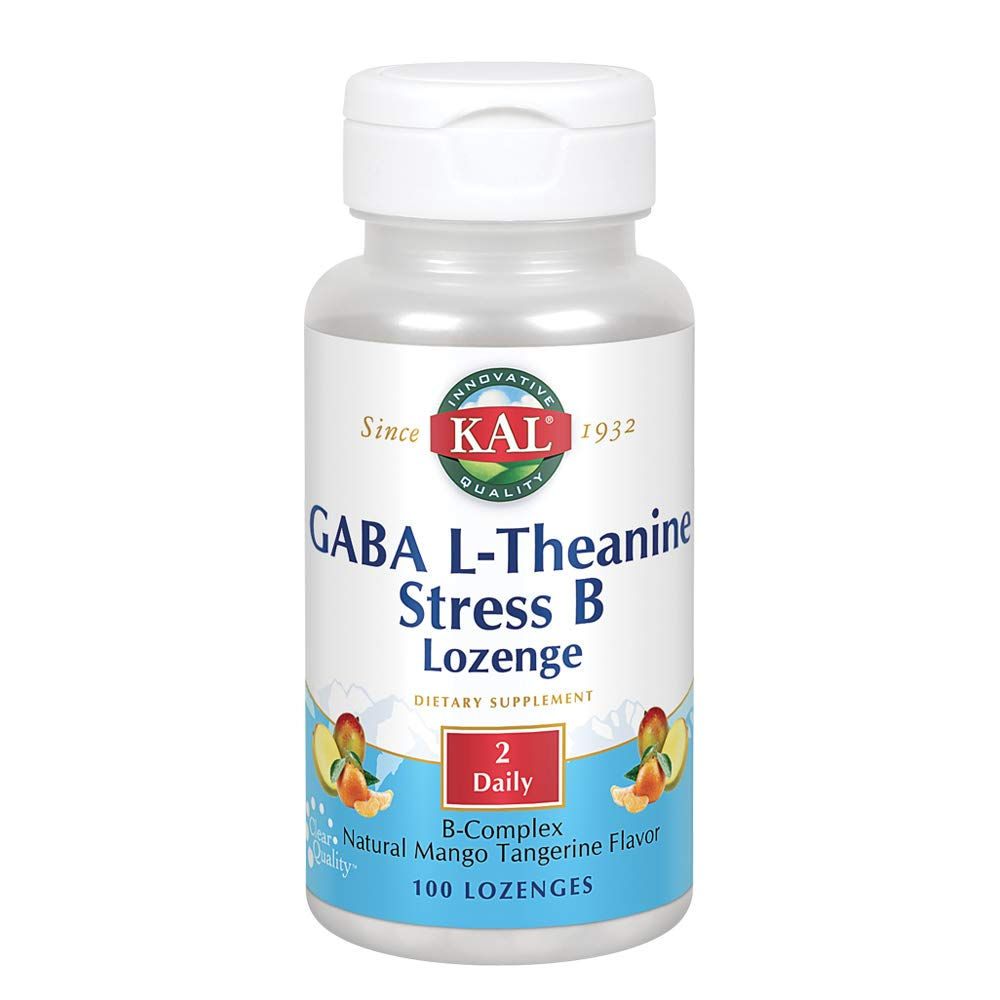How might the flavor of this supplement affect its appeal and consumption? The natural mango tangerine flavor is likely to enhance the appeal and consumption of this supplement. Pleasant flavors can make taking daily supplements a more enjoyable experience, thereby increasing adherence to the recommended dosage. Additionally, fruity flavors like mango and tangerine are generally popular and may mask any potential bitterness of the active ingredients. What other factors could influence the regular consumption of this supplement? Other factors that could influence regular consumption include the ease of using lozenges compared to other forms like pills or powders, the perceived effectiveness of the supplement, personal health goals, and dietary restrictions or preferences. Packaging and branding, including trust in the manufacturer and product reviews, also play significant roles. Regular reminders and the establishment of a daily routine can support consistent use as well. Can you imagine a scenario where someone might forget to take this supplement? Sure! Imagine a busy professional who starts the day with early meetings and barely has time for breakfast. They might keep the supplement in a kitchen cabinet and overlook it in the morning rush. By the end of a long workday, they might be too tired and forgetful to remember the lozenge. Placing the supplement in a more visible spot, like near their coffee maker or toothbrush, could help serve as a daily reminder. 